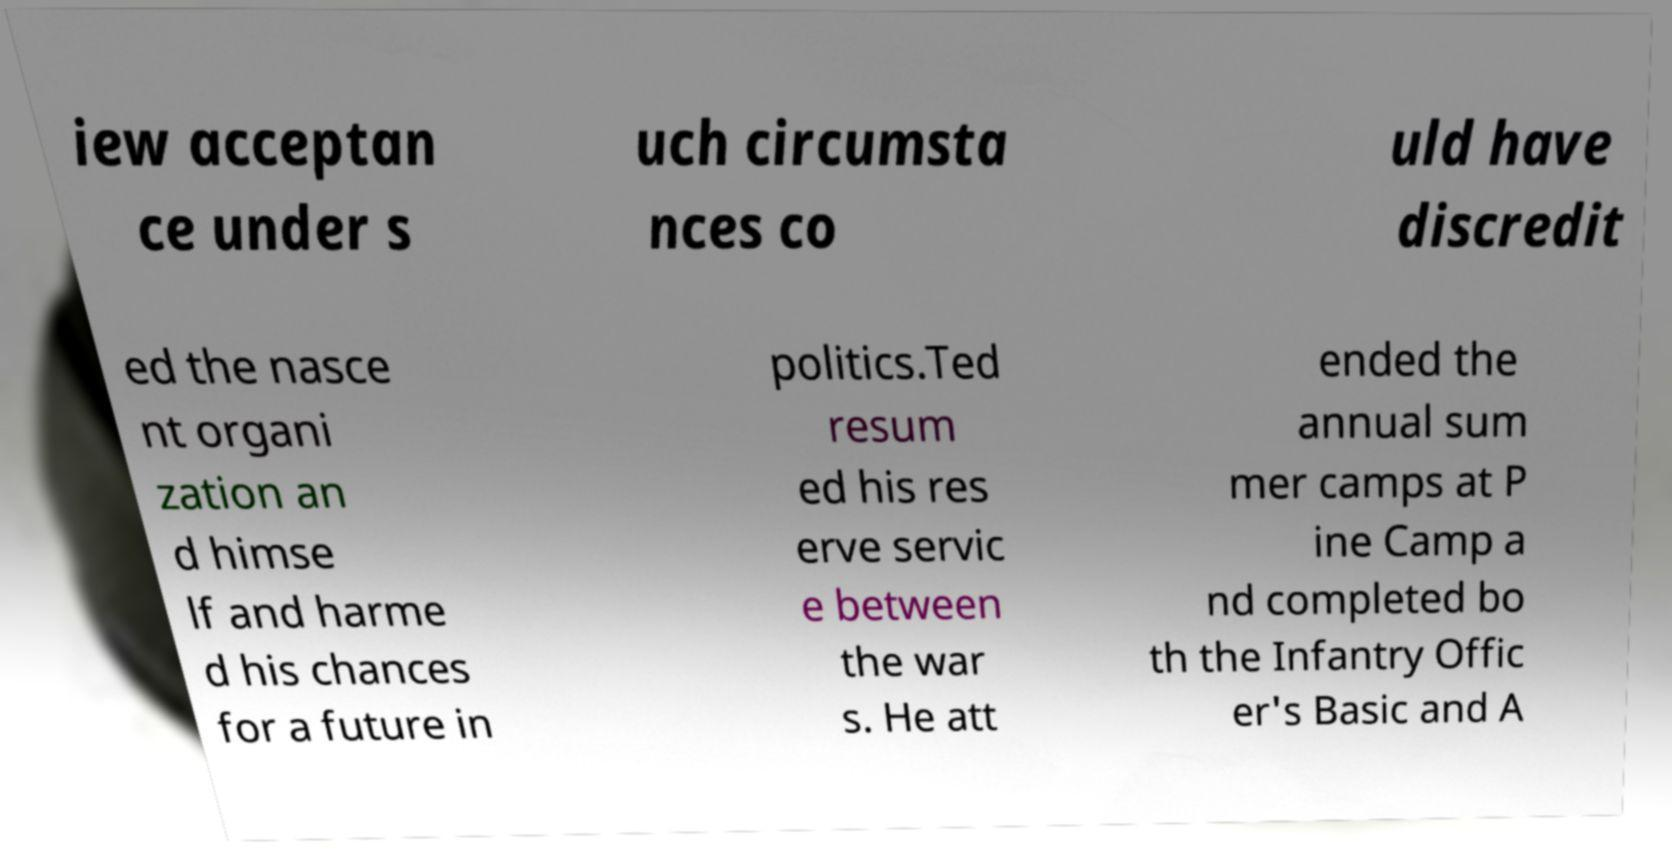Could you assist in decoding the text presented in this image and type it out clearly? iew acceptan ce under s uch circumsta nces co uld have discredit ed the nasce nt organi zation an d himse lf and harme d his chances for a future in politics.Ted resum ed his res erve servic e between the war s. He att ended the annual sum mer camps at P ine Camp a nd completed bo th the Infantry Offic er's Basic and A 